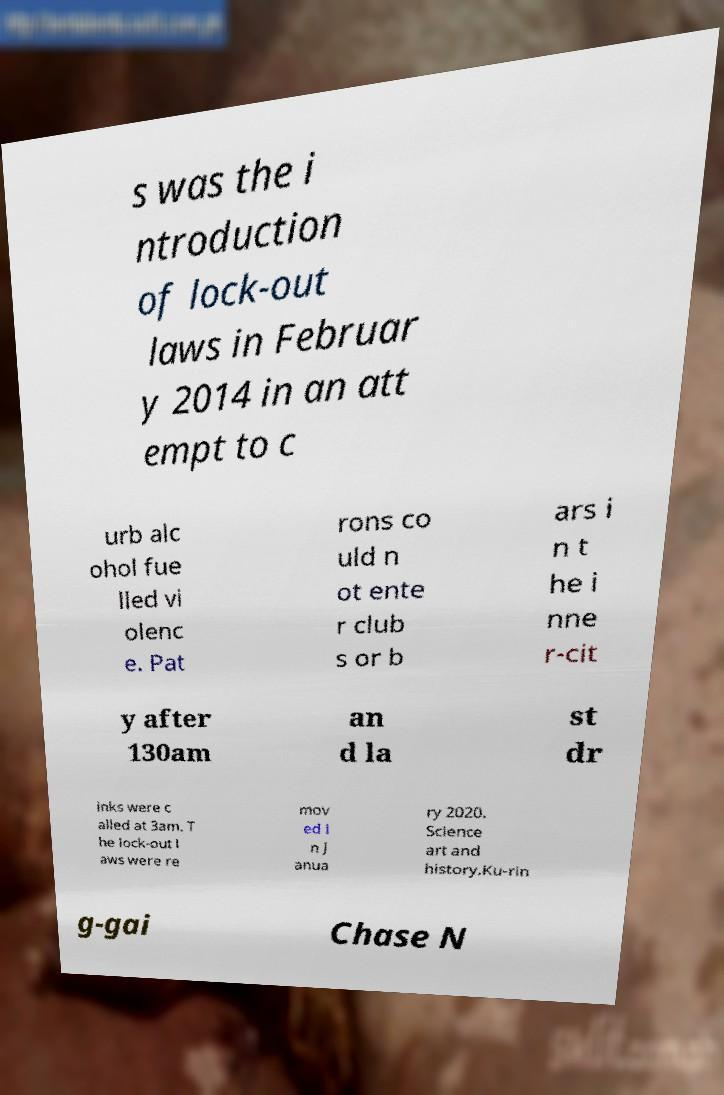Could you assist in decoding the text presented in this image and type it out clearly? s was the i ntroduction of lock-out laws in Februar y 2014 in an att empt to c urb alc ohol fue lled vi olenc e. Pat rons co uld n ot ente r club s or b ars i n t he i nne r-cit y after 130am an d la st dr inks were c alled at 3am. T he lock-out l aws were re mov ed i n J anua ry 2020. Science art and history.Ku-rin g-gai Chase N 